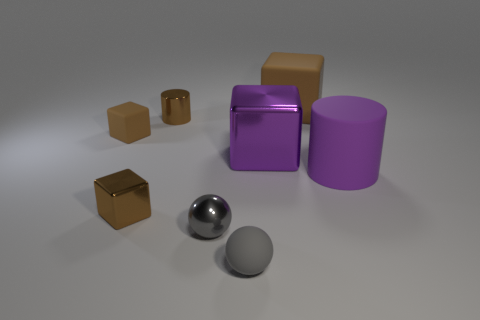Do the purple thing that is on the left side of the purple matte object and the small brown cylinder have the same material?
Provide a succinct answer. Yes. The purple shiny object is what shape?
Offer a very short reply. Cube. What number of yellow objects are metallic balls or shiny cylinders?
Keep it short and to the point. 0. What number of other objects are the same material as the purple cube?
Your answer should be very brief. 3. There is a small brown metallic object that is behind the purple rubber thing; is its shape the same as the big purple matte thing?
Give a very brief answer. Yes. Are there any small blocks?
Your response must be concise. Yes. Is there anything else that has the same shape as the large purple matte thing?
Offer a very short reply. Yes. Is the number of purple matte cylinders left of the large brown matte thing greater than the number of small metal cubes?
Make the answer very short. No. Are there any blocks on the right side of the large purple metal cube?
Your answer should be very brief. Yes. Do the purple rubber cylinder and the matte ball have the same size?
Your response must be concise. No. 